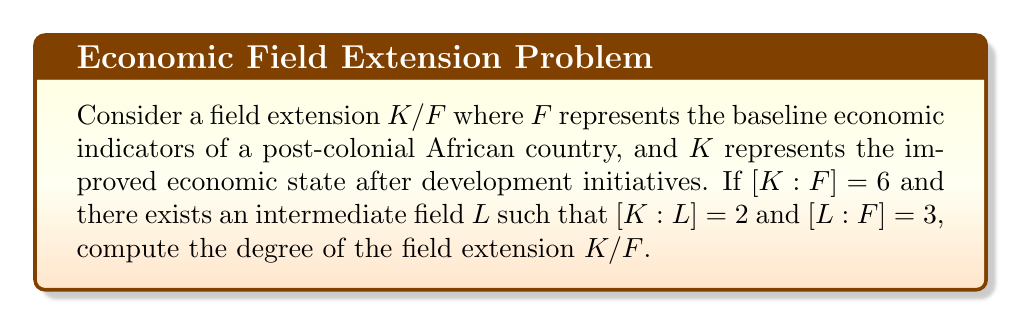What is the answer to this math problem? To solve this problem, we'll use the fundamental theorem of field extensions, which states that for field extensions $K/L$ and $L/F$, we have:

$$[K:F] = [K:L][L:F]$$

Given:
1. $[K:F] = 6$
2. $[K:L] = 2$
3. $[L:F] = 3$

We can verify the relationship between these field extensions:

$$[K:F] = [K:L][L:F] = 2 \cdot 3 = 6$$

This confirms that the given information is consistent with the fundamental theorem of field extensions.

The degree of the field extension $K/F$ is defined as $[K:F]$, which is given as 6.

This degree represents the dimension of $K$ as a vector space over $F$. In the context of economic development, it could be interpreted as the complexity or extent of economic growth achieved through development initiatives.
Answer: $[K:F] = 6$ 